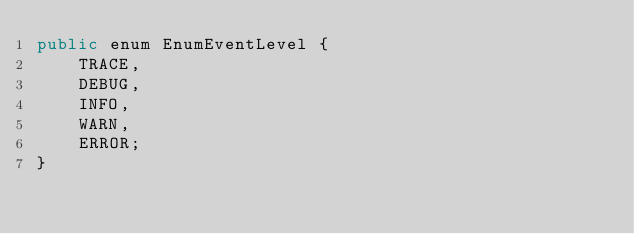Convert code to text. <code><loc_0><loc_0><loc_500><loc_500><_Java_>public enum EnumEventLevel {
    TRACE,
    DEBUG,
    INFO,
    WARN,
    ERROR;
}
</code> 